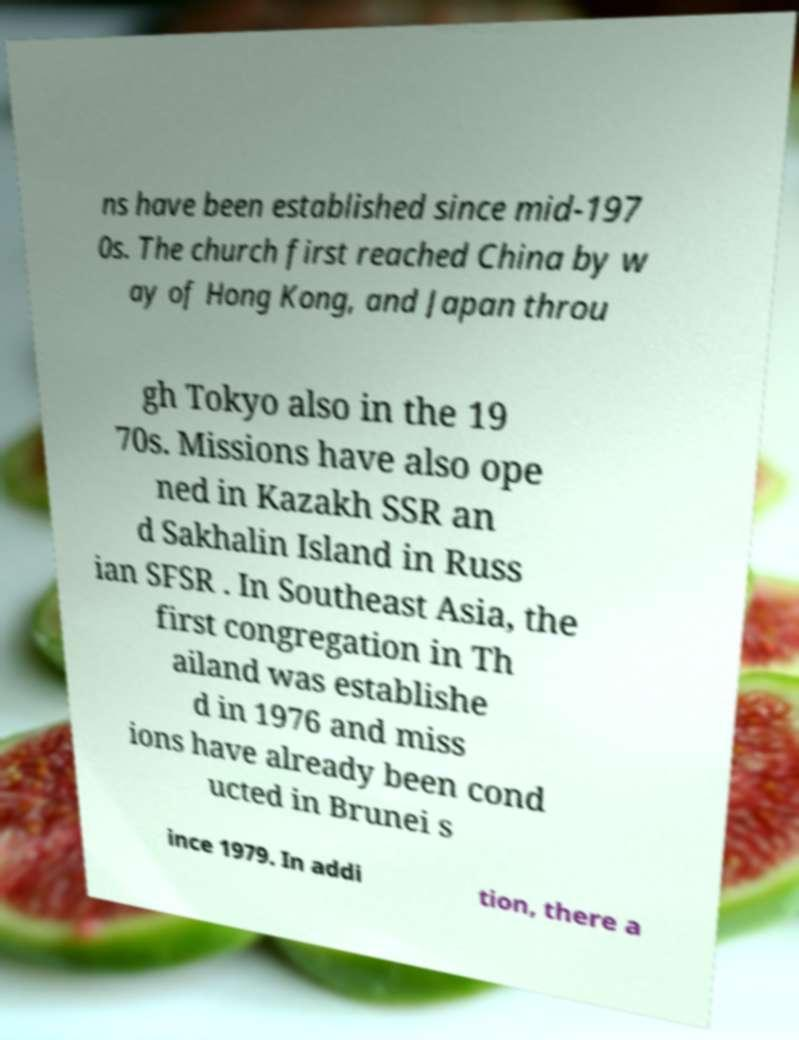Can you read and provide the text displayed in the image?This photo seems to have some interesting text. Can you extract and type it out for me? ns have been established since mid-197 0s. The church first reached China by w ay of Hong Kong, and Japan throu gh Tokyo also in the 19 70s. Missions have also ope ned in Kazakh SSR an d Sakhalin Island in Russ ian SFSR . In Southeast Asia, the first congregation in Th ailand was establishe d in 1976 and miss ions have already been cond ucted in Brunei s ince 1979. In addi tion, there a 